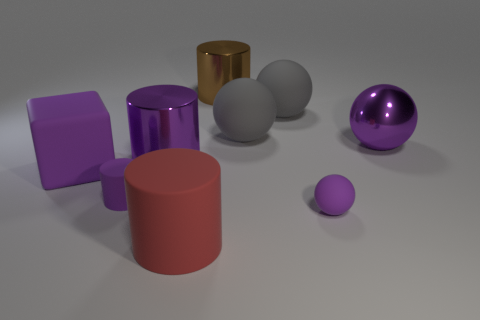Add 1 large purple spheres. How many objects exist? 10 Subtract all blocks. How many objects are left? 8 Add 2 purple matte spheres. How many purple matte spheres are left? 3 Add 4 large yellow shiny things. How many large yellow shiny things exist? 4 Subtract 1 gray balls. How many objects are left? 8 Subtract all small shiny objects. Subtract all big rubber blocks. How many objects are left? 8 